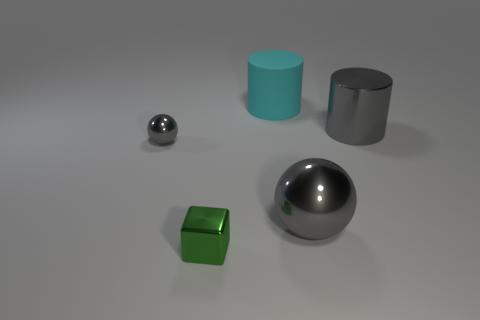There is a metallic object that is in front of the tiny sphere and behind the small green block; how big is it?
Provide a succinct answer. Large. There is a large cylinder to the right of the big matte cylinder; is its color the same as the thing on the left side of the small green cube?
Make the answer very short. Yes. How many tiny metal objects are the same color as the large metallic ball?
Provide a short and direct response. 1. There is a ball to the left of the cyan object; does it have the same size as the big cyan cylinder?
Provide a short and direct response. No. What color is the big thing that is both behind the large shiny sphere and left of the big gray cylinder?
Make the answer very short. Cyan. What number of objects are gray objects or gray balls that are on the left side of the tiny green shiny cube?
Your answer should be very brief. 3. The large cyan cylinder that is behind the big gray metal object that is to the left of the metallic thing behind the small gray sphere is made of what material?
Provide a succinct answer. Rubber. Is there anything else that is the same material as the large cyan thing?
Your response must be concise. No. Do the metallic sphere on the right side of the green metal cube and the small metallic cube have the same color?
Offer a very short reply. No. How many red objects are either tiny objects or large matte things?
Your answer should be compact. 0. 